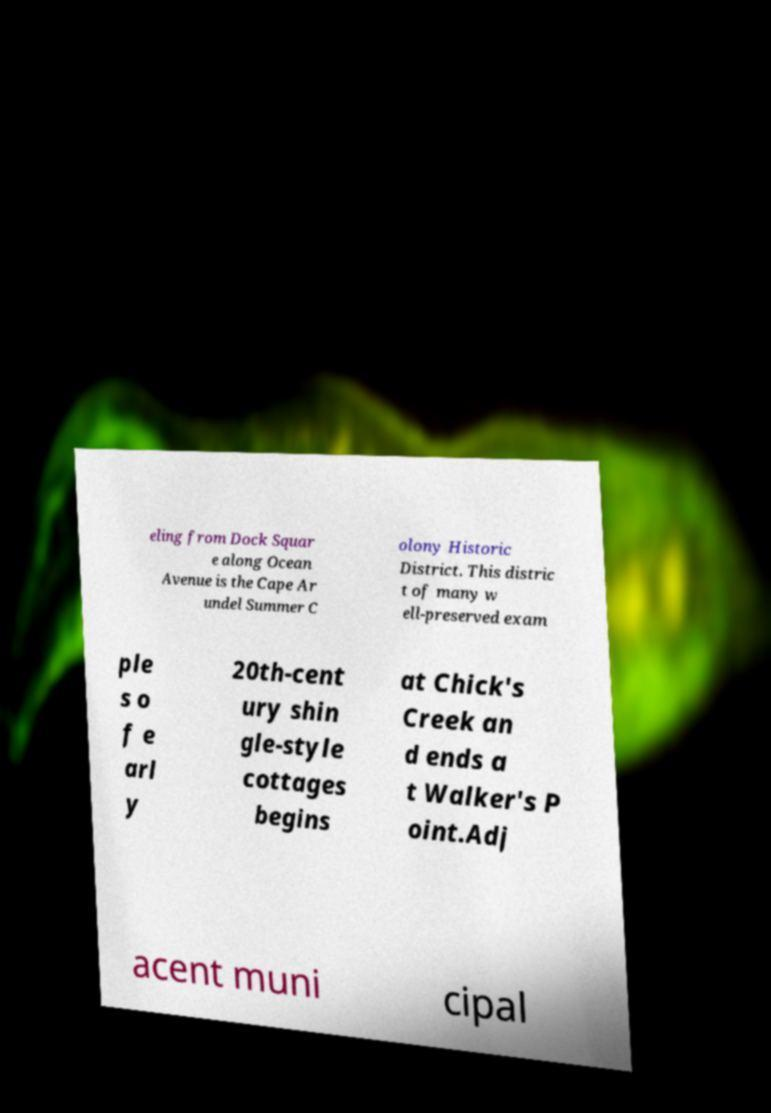Could you assist in decoding the text presented in this image and type it out clearly? eling from Dock Squar e along Ocean Avenue is the Cape Ar undel Summer C olony Historic District. This distric t of many w ell-preserved exam ple s o f e arl y 20th-cent ury shin gle-style cottages begins at Chick's Creek an d ends a t Walker's P oint.Adj acent muni cipal 